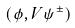Convert formula to latex. <formula><loc_0><loc_0><loc_500><loc_500>( \phi , V \psi ^ { \pm } )</formula> 